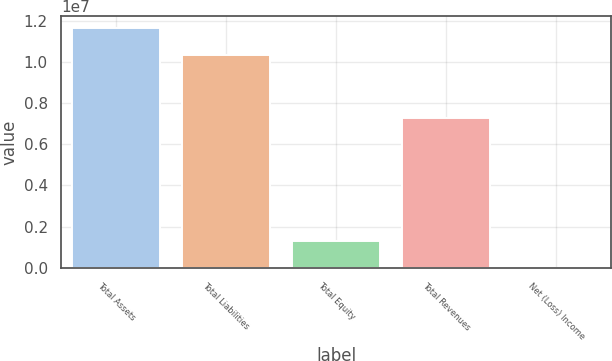Convert chart to OTSL. <chart><loc_0><loc_0><loc_500><loc_500><bar_chart><fcel>Total Assets<fcel>Total Liabilities<fcel>Total Equity<fcel>Total Revenues<fcel>Net (Loss) Income<nl><fcel>1.1655e+07<fcel>1.0347e+07<fcel>1.308e+06<fcel>7.281e+06<fcel>8000<nl></chart> 